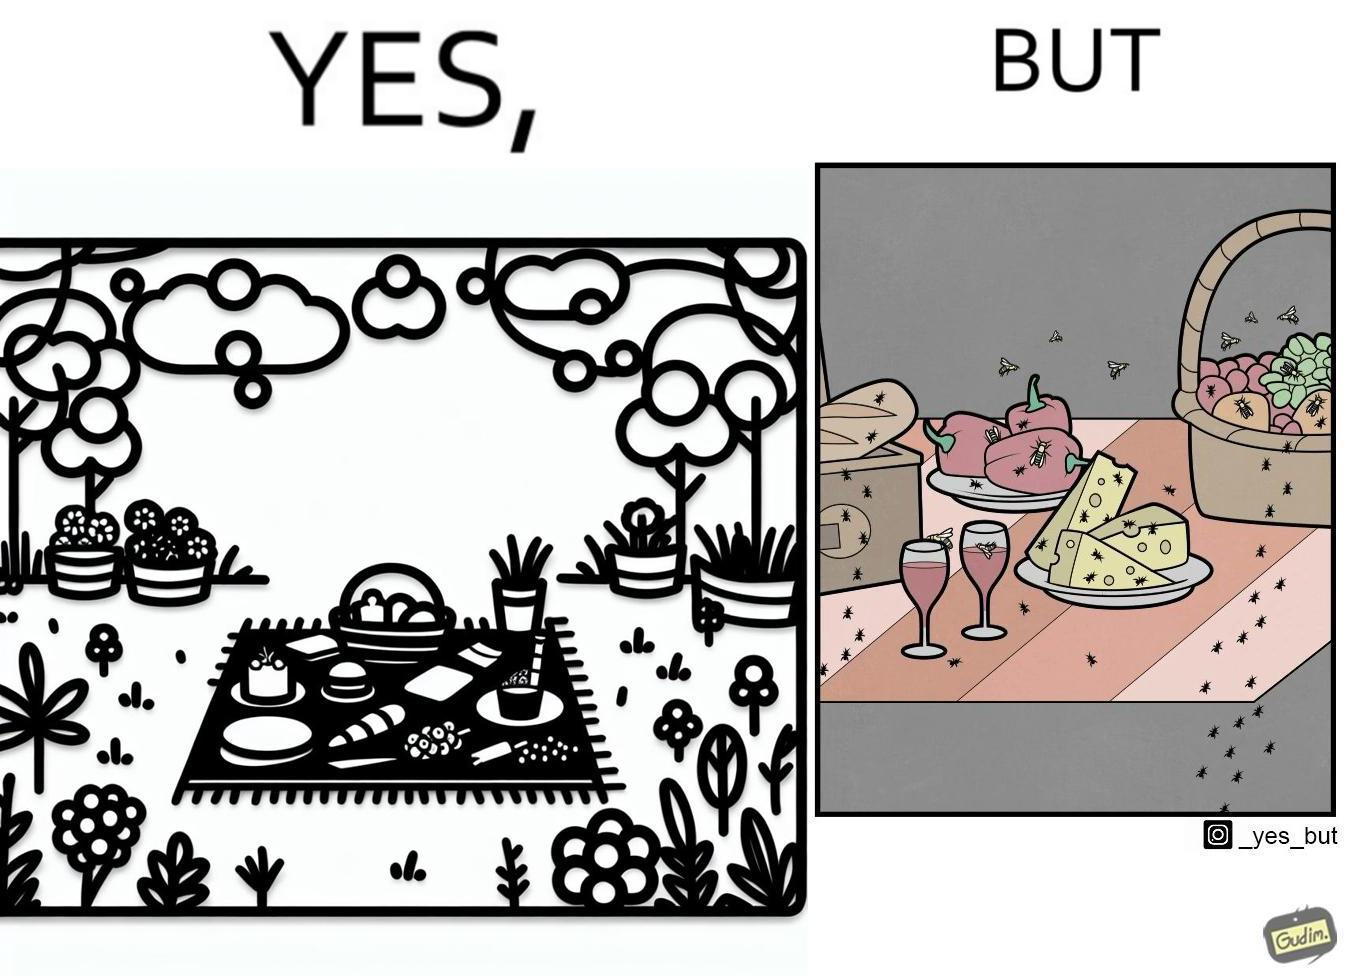Describe the content of this image. The Picture shows that although we enjoy food in garden but there are some consequences of eating food in garden. Many bugs and bees are attracted towards our food and make our food sometimes non-eatable. 